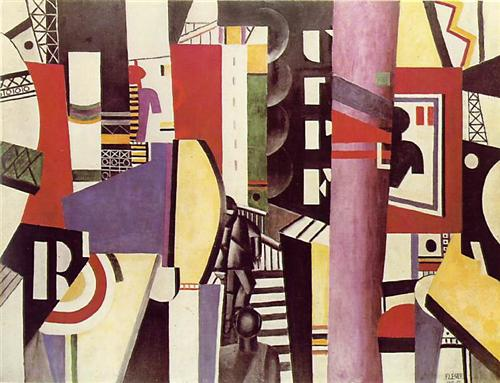Write a detailed description of the given image. The image presented is an evocative piece exemplifying the abstract and Cubist art styles. It features a dynamic composition of geometric shapes and intersecting lines that create a vibrant and layered visual experience. The palette includes bold and contrasting colors like red, yellow, green, purple, black, and white, which are harmoniously distributed across the canvas. The artist brilliantly manipulates form and color to evoke a sense of depth and motion, characteristic of Cubist art. Through the use of overlapping shapes and fragmented forms, the artwork invites viewers to engage in an imaginative interpretation, prompting an emotional and introspective response. It's a captivating piece that draws the observer into its multifaceted world, reflecting the complex interplay of shapes, colors, and perspectives that define abstract and Cubist aesthetics. 